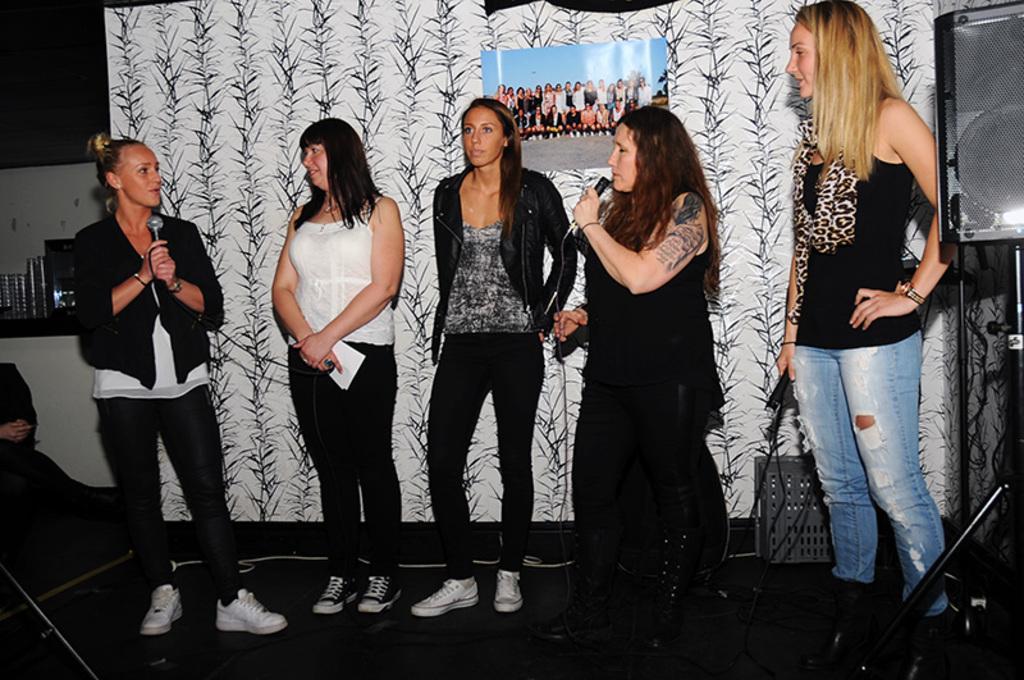Describe this image in one or two sentences. In this image we can see few women are standing on the floor and among the two women are holding mics in their hands and a woman is holding a paper in the hand. In the background there is a photograph on the curtain and on the right side there is a speaker on a stand and on the left side there are glasses and objects on a platform and a person is sitting. 